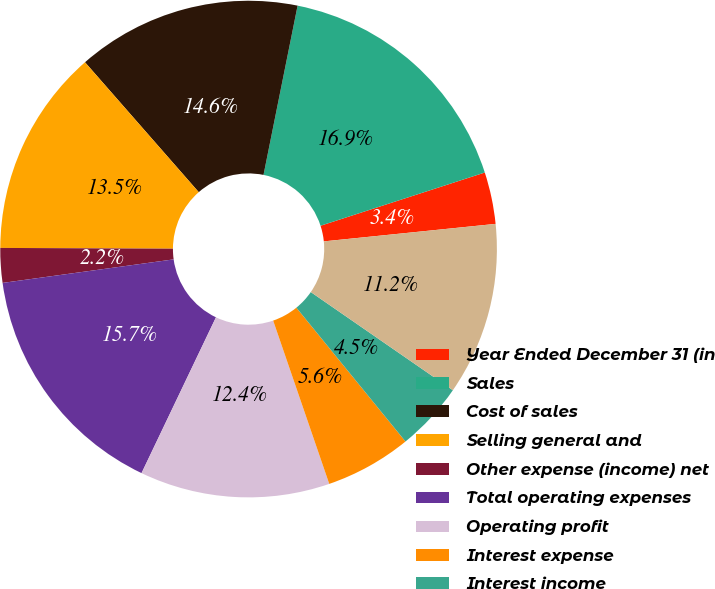Convert chart to OTSL. <chart><loc_0><loc_0><loc_500><loc_500><pie_chart><fcel>Year Ended December 31 (in<fcel>Sales<fcel>Cost of sales<fcel>Selling general and<fcel>Other expense (income) net<fcel>Total operating expenses<fcel>Operating profit<fcel>Interest expense<fcel>Interest income<fcel>Earnings before income taxes<nl><fcel>3.37%<fcel>16.85%<fcel>14.61%<fcel>13.48%<fcel>2.25%<fcel>15.73%<fcel>12.36%<fcel>5.62%<fcel>4.49%<fcel>11.24%<nl></chart> 